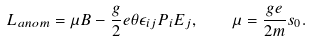<formula> <loc_0><loc_0><loc_500><loc_500>L _ { a n o m } = \mu B - \frac { g } { 2 } e \theta \epsilon _ { i j } P _ { i } E _ { j } , \quad \mu = \frac { g e } { 2 m } s _ { 0 } .</formula> 